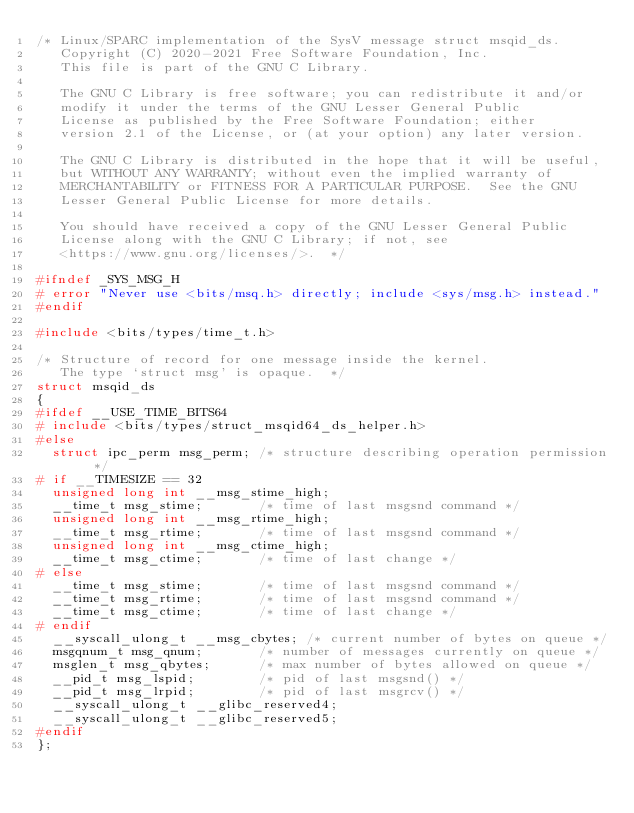Convert code to text. <code><loc_0><loc_0><loc_500><loc_500><_C_>/* Linux/SPARC implementation of the SysV message struct msqid_ds.
   Copyright (C) 2020-2021 Free Software Foundation, Inc.
   This file is part of the GNU C Library.

   The GNU C Library is free software; you can redistribute it and/or
   modify it under the terms of the GNU Lesser General Public
   License as published by the Free Software Foundation; either
   version 2.1 of the License, or (at your option) any later version.

   The GNU C Library is distributed in the hope that it will be useful,
   but WITHOUT ANY WARRANTY; without even the implied warranty of
   MERCHANTABILITY or FITNESS FOR A PARTICULAR PURPOSE.  See the GNU
   Lesser General Public License for more details.

   You should have received a copy of the GNU Lesser General Public
   License along with the GNU C Library; if not, see
   <https://www.gnu.org/licenses/>.  */

#ifndef _SYS_MSG_H
# error "Never use <bits/msq.h> directly; include <sys/msg.h> instead."
#endif

#include <bits/types/time_t.h>

/* Structure of record for one message inside the kernel.
   The type `struct msg' is opaque.  */
struct msqid_ds
{
#ifdef __USE_TIME_BITS64
# include <bits/types/struct_msqid64_ds_helper.h>
#else
  struct ipc_perm msg_perm;	/* structure describing operation permission */
# if __TIMESIZE == 32
  unsigned long int __msg_stime_high;
  __time_t msg_stime;		/* time of last msgsnd command */
  unsigned long int __msg_rtime_high;
  __time_t msg_rtime;		/* time of last msgsnd command */
  unsigned long int __msg_ctime_high;
  __time_t msg_ctime;		/* time of last change */
# else
  __time_t msg_stime;		/* time of last msgsnd command */
  __time_t msg_rtime;		/* time of last msgsnd command */
  __time_t msg_ctime;		/* time of last change */
# endif
  __syscall_ulong_t __msg_cbytes; /* current number of bytes on queue */
  msgqnum_t msg_qnum;		/* number of messages currently on queue */
  msglen_t msg_qbytes;		/* max number of bytes allowed on queue */
  __pid_t msg_lspid;		/* pid of last msgsnd() */
  __pid_t msg_lrpid;		/* pid of last msgrcv() */
  __syscall_ulong_t __glibc_reserved4;
  __syscall_ulong_t __glibc_reserved5;
#endif
};</code> 